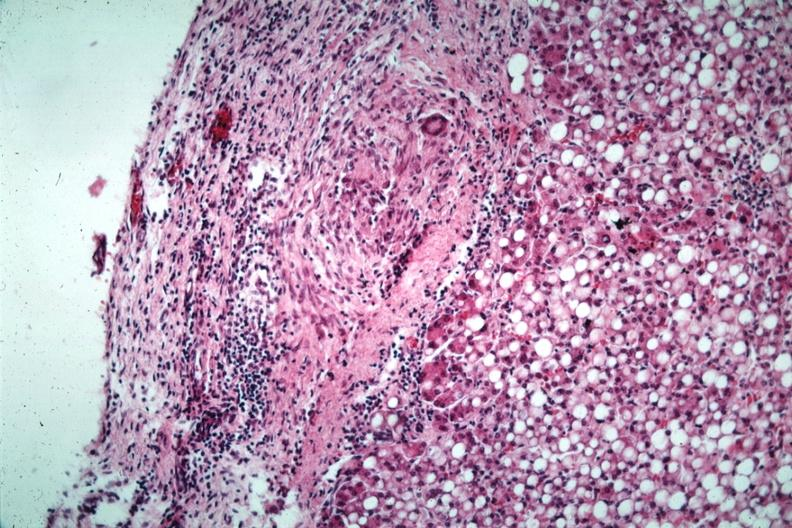do liver with tuberculoid granuloma in glissons capsule quite good liver has marked fatty change?
Answer the question using a single word or phrase. Yes 